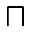<formula> <loc_0><loc_0><loc_500><loc_500>\sqcap</formula> 